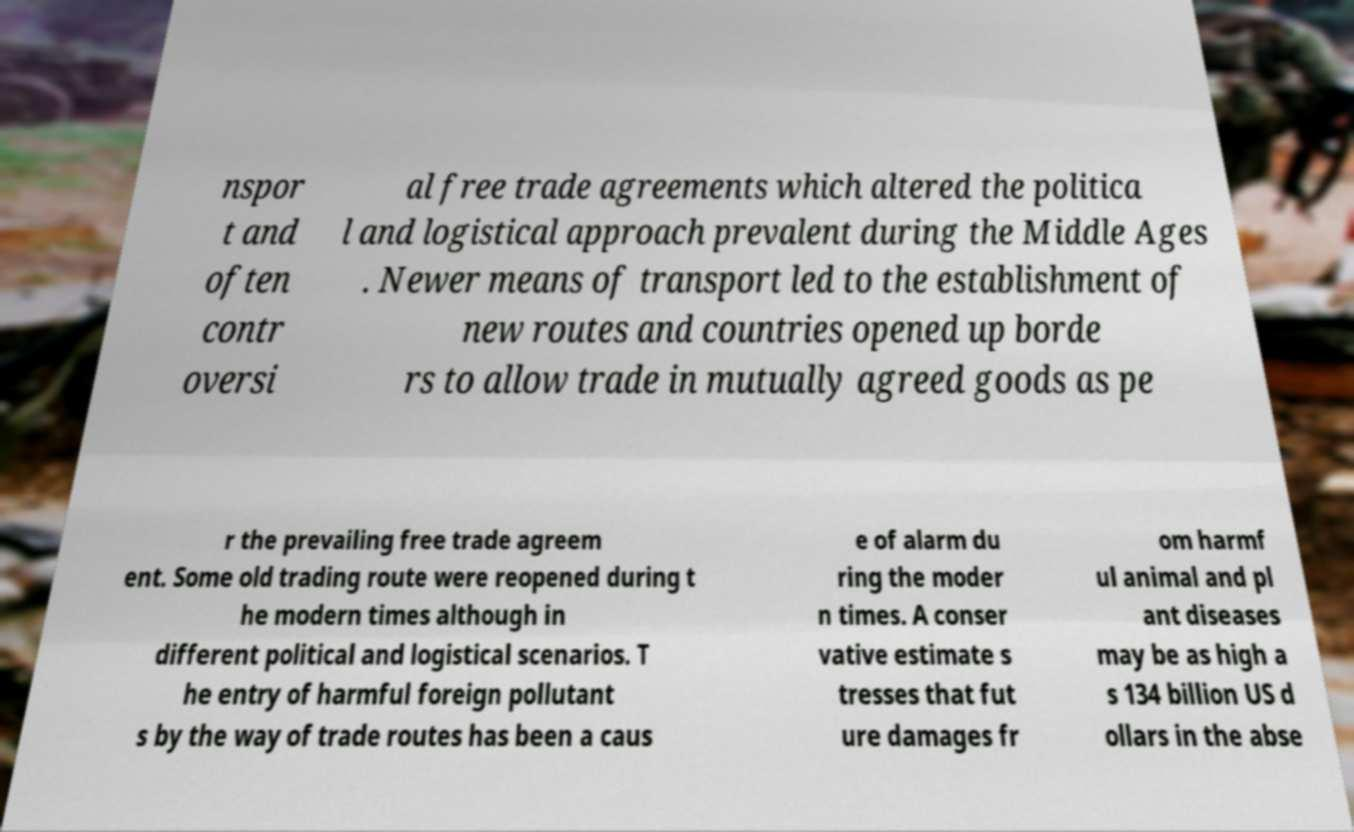Could you extract and type out the text from this image? nspor t and often contr oversi al free trade agreements which altered the politica l and logistical approach prevalent during the Middle Ages . Newer means of transport led to the establishment of new routes and countries opened up borde rs to allow trade in mutually agreed goods as pe r the prevailing free trade agreem ent. Some old trading route were reopened during t he modern times although in different political and logistical scenarios. T he entry of harmful foreign pollutant s by the way of trade routes has been a caus e of alarm du ring the moder n times. A conser vative estimate s tresses that fut ure damages fr om harmf ul animal and pl ant diseases may be as high a s 134 billion US d ollars in the abse 